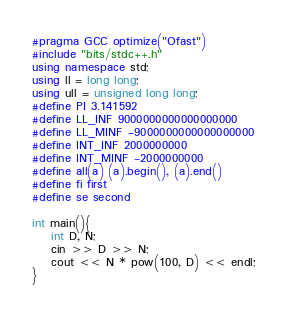Convert code to text. <code><loc_0><loc_0><loc_500><loc_500><_C++_>#pragma GCC optimize("Ofast")
#include "bits/stdc++.h"
using namespace std;
using ll = long long;
using ull = unsigned long long;
#define PI 3.141592
#define LL_INF 9000000000000000000
#define LL_MINF -9000000000000000000
#define INT_INF 2000000000
#define INT_MINF -2000000000
#define all(a) (a).begin(), (a).end()
#define fi first
#define se second

int main(){
    int D, N;
    cin >> D >> N;
    cout << N * pow(100, D) << endl;
}
</code> 